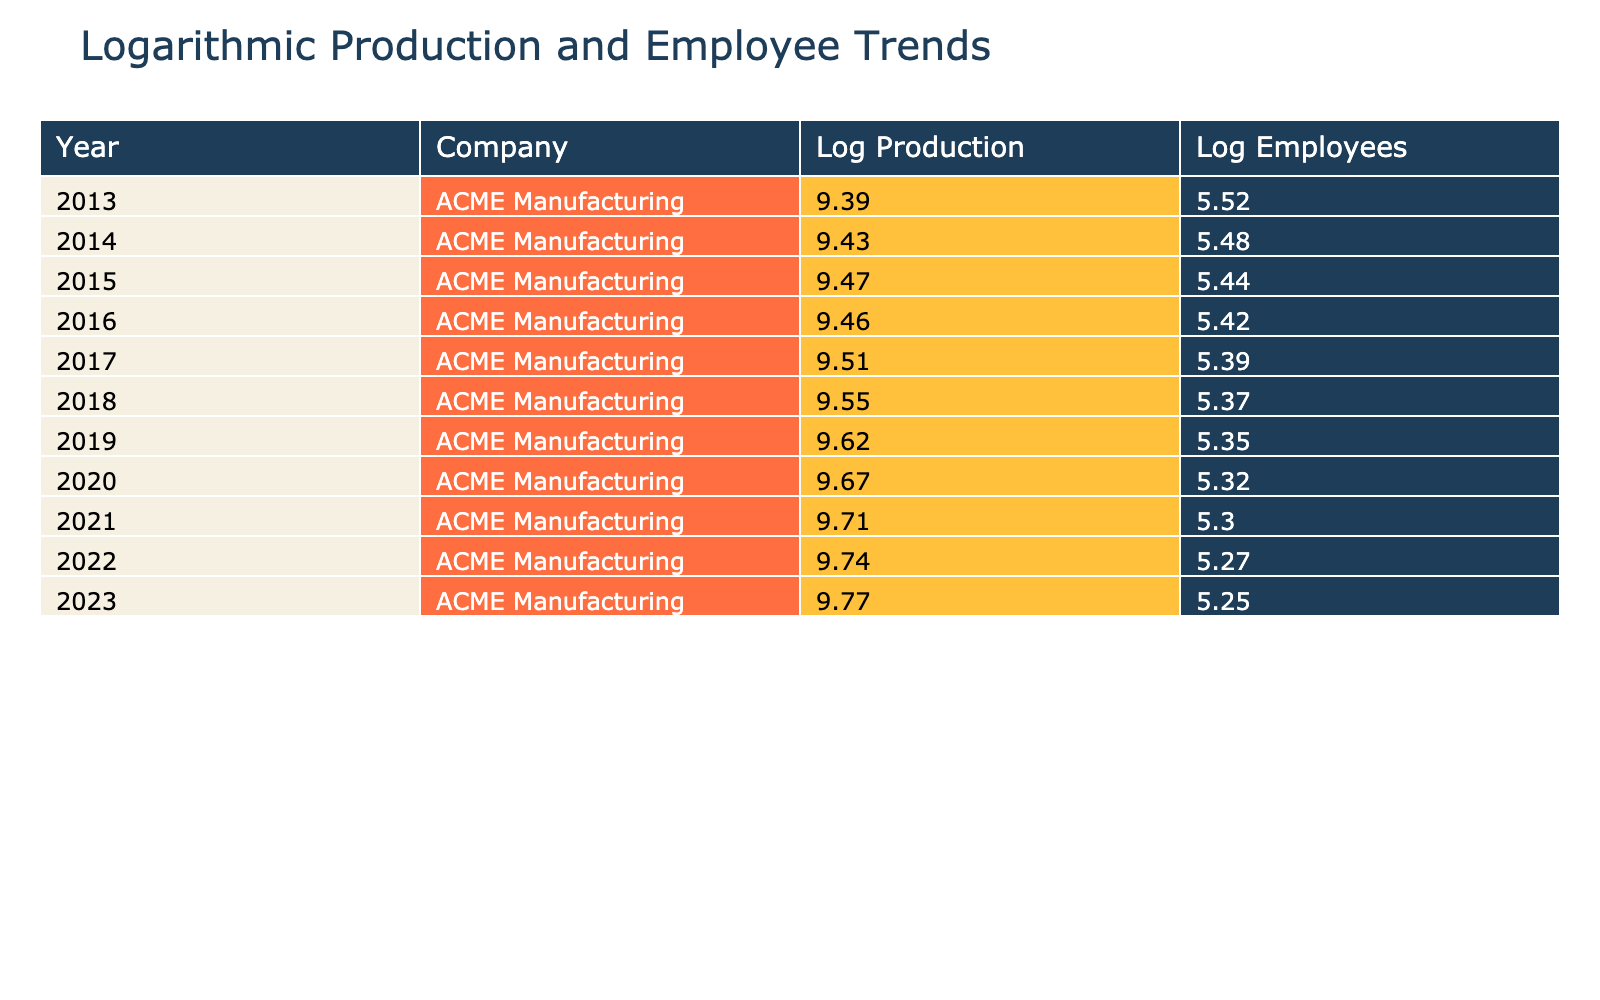What was the production output in 2016? In the row for the year 2016, the production output is listed as 12800.
Answer: 12800 How many employees did ACME Manufacturing have in 2015? Referring to the year 2015 in the table, the employee count is recorded as 230.
Answer: 230 What is the average production output over the last decade? To find the average, sum all production outputs (12000 + 12500 + 13000 + 12800 + 13500 + 14000 + 15000 + 15800 + 16500 + 17000 + 17500) = 157100. There are 11 years, so the average is 157100 / 11 = 14282.73.
Answer: 14282.73 Did the production output increase every year? By examining the production output for each year, we see that in 2016 the output decreased from 13000 to 12800. Therefore, the statement is false.
Answer: No What was the total decrease in employee count from 2013 to 2023? The employee count in 2013 was 250 and in 2023 it was 190. The total decrease can be calculated as 250 - 190 = 60.
Answer: 60 What was the production output in the year with the highest employee count? The highest employee count is 250 in 2013, and the production output for that year is 12000.
Answer: 12000 What is the percentage increase in production output from 2013 to 2023? The production output in 2013 was 12000, and in 2023 it was 17500. The increase is 17500 - 12000 = 5500. To find the percentage increase, (5500 / 12000) * 100 = 45.83%.
Answer: 45.83% Was there ever a year when the production output and employee count both increased compared to the previous year? Comparing consecutive years, we see that from 2016 to 2017, the production output increased from 12800 to 13500 while the employee count decreased from 225 to 220. Thus such a year did not occur.
Answer: No What was the logarithmic value of the production output in 2020? For the year 2020, the production output is 15800. The logarithmic value calculated is log(15800) which is approximately 9.066.
Answer: 9.07 